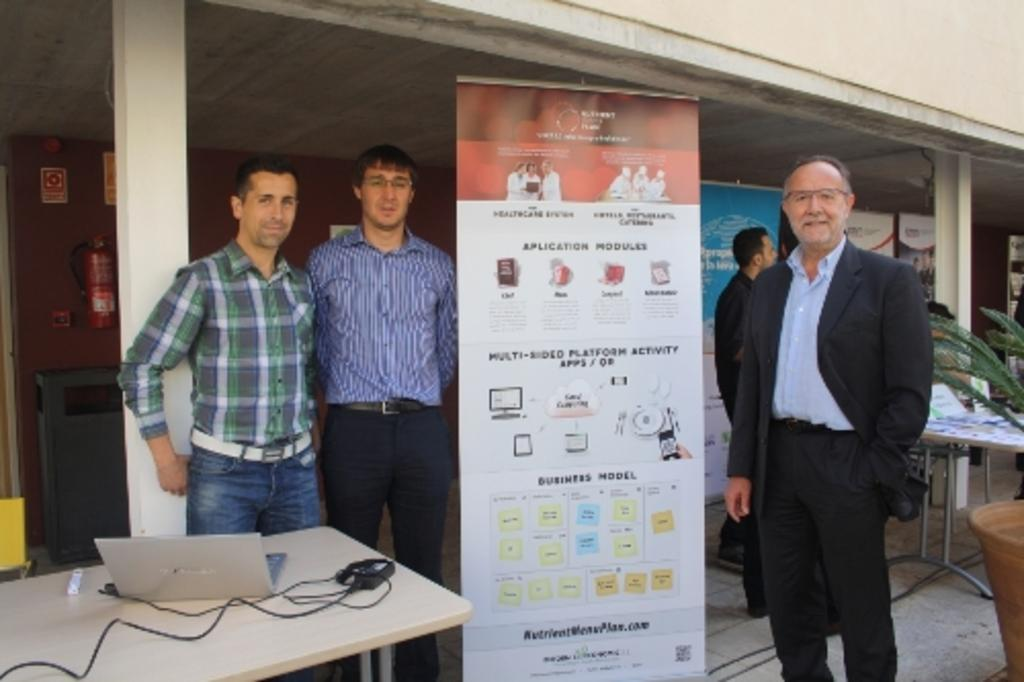How many people are present in the image? There are four persons standing in the image. Where are the persons standing? The persons are standing on the floor. What can be seen hanging in the image? There is a banner in the image. What is on the table in the image? There is a laptop on the table. What architectural feature is present in the image? There is a pillar in the image. What type of background is visible in the image? There is a wall in the image. What type of record can be seen being played on the laptop in the image? There is no record being played on the laptop in the image; it is a laptop on a table. What type of amusement park ride is visible in the image? There is no amusement park ride present in the image. 